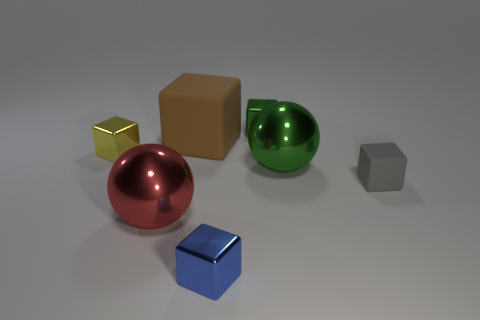There is a red thing; is its shape the same as the large metal object that is right of the red metal object? yes 